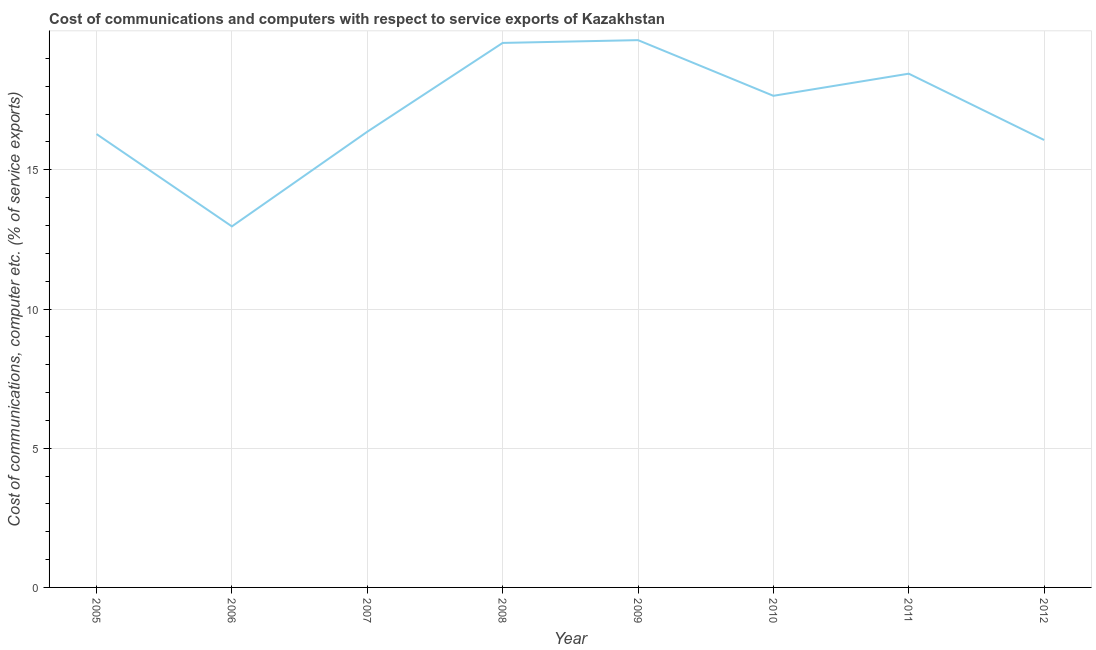What is the cost of communications and computer in 2007?
Keep it short and to the point. 16.37. Across all years, what is the maximum cost of communications and computer?
Your answer should be compact. 19.66. Across all years, what is the minimum cost of communications and computer?
Your response must be concise. 12.97. In which year was the cost of communications and computer minimum?
Offer a terse response. 2006. What is the sum of the cost of communications and computer?
Offer a very short reply. 137.02. What is the difference between the cost of communications and computer in 2010 and 2011?
Keep it short and to the point. -0.79. What is the average cost of communications and computer per year?
Provide a short and direct response. 17.13. What is the median cost of communications and computer?
Give a very brief answer. 17.01. What is the ratio of the cost of communications and computer in 2005 to that in 2006?
Your answer should be compact. 1.26. Is the cost of communications and computer in 2007 less than that in 2011?
Your answer should be compact. Yes. Is the difference between the cost of communications and computer in 2007 and 2010 greater than the difference between any two years?
Offer a very short reply. No. What is the difference between the highest and the second highest cost of communications and computer?
Offer a terse response. 0.1. What is the difference between the highest and the lowest cost of communications and computer?
Offer a terse response. 6.69. Does the cost of communications and computer monotonically increase over the years?
Give a very brief answer. No. What is the difference between two consecutive major ticks on the Y-axis?
Your answer should be compact. 5. Are the values on the major ticks of Y-axis written in scientific E-notation?
Give a very brief answer. No. What is the title of the graph?
Your answer should be very brief. Cost of communications and computers with respect to service exports of Kazakhstan. What is the label or title of the X-axis?
Your answer should be very brief. Year. What is the label or title of the Y-axis?
Provide a succinct answer. Cost of communications, computer etc. (% of service exports). What is the Cost of communications, computer etc. (% of service exports) in 2005?
Your answer should be very brief. 16.28. What is the Cost of communications, computer etc. (% of service exports) in 2006?
Your response must be concise. 12.97. What is the Cost of communications, computer etc. (% of service exports) of 2007?
Give a very brief answer. 16.37. What is the Cost of communications, computer etc. (% of service exports) in 2008?
Provide a succinct answer. 19.56. What is the Cost of communications, computer etc. (% of service exports) in 2009?
Provide a succinct answer. 19.66. What is the Cost of communications, computer etc. (% of service exports) of 2010?
Keep it short and to the point. 17.66. What is the Cost of communications, computer etc. (% of service exports) of 2011?
Give a very brief answer. 18.45. What is the Cost of communications, computer etc. (% of service exports) of 2012?
Provide a short and direct response. 16.07. What is the difference between the Cost of communications, computer etc. (% of service exports) in 2005 and 2006?
Keep it short and to the point. 3.32. What is the difference between the Cost of communications, computer etc. (% of service exports) in 2005 and 2007?
Give a very brief answer. -0.08. What is the difference between the Cost of communications, computer etc. (% of service exports) in 2005 and 2008?
Keep it short and to the point. -3.27. What is the difference between the Cost of communications, computer etc. (% of service exports) in 2005 and 2009?
Ensure brevity in your answer.  -3.37. What is the difference between the Cost of communications, computer etc. (% of service exports) in 2005 and 2010?
Keep it short and to the point. -1.37. What is the difference between the Cost of communications, computer etc. (% of service exports) in 2005 and 2011?
Offer a very short reply. -2.17. What is the difference between the Cost of communications, computer etc. (% of service exports) in 2005 and 2012?
Your response must be concise. 0.21. What is the difference between the Cost of communications, computer etc. (% of service exports) in 2006 and 2007?
Make the answer very short. -3.4. What is the difference between the Cost of communications, computer etc. (% of service exports) in 2006 and 2008?
Your answer should be compact. -6.59. What is the difference between the Cost of communications, computer etc. (% of service exports) in 2006 and 2009?
Provide a short and direct response. -6.69. What is the difference between the Cost of communications, computer etc. (% of service exports) in 2006 and 2010?
Offer a terse response. -4.69. What is the difference between the Cost of communications, computer etc. (% of service exports) in 2006 and 2011?
Make the answer very short. -5.49. What is the difference between the Cost of communications, computer etc. (% of service exports) in 2006 and 2012?
Provide a short and direct response. -3.1. What is the difference between the Cost of communications, computer etc. (% of service exports) in 2007 and 2008?
Offer a very short reply. -3.19. What is the difference between the Cost of communications, computer etc. (% of service exports) in 2007 and 2009?
Offer a very short reply. -3.29. What is the difference between the Cost of communications, computer etc. (% of service exports) in 2007 and 2010?
Give a very brief answer. -1.29. What is the difference between the Cost of communications, computer etc. (% of service exports) in 2007 and 2011?
Your answer should be very brief. -2.09. What is the difference between the Cost of communications, computer etc. (% of service exports) in 2007 and 2012?
Keep it short and to the point. 0.3. What is the difference between the Cost of communications, computer etc. (% of service exports) in 2008 and 2009?
Ensure brevity in your answer.  -0.1. What is the difference between the Cost of communications, computer etc. (% of service exports) in 2008 and 2010?
Your answer should be very brief. 1.9. What is the difference between the Cost of communications, computer etc. (% of service exports) in 2008 and 2011?
Your response must be concise. 1.1. What is the difference between the Cost of communications, computer etc. (% of service exports) in 2008 and 2012?
Offer a very short reply. 3.49. What is the difference between the Cost of communications, computer etc. (% of service exports) in 2009 and 2010?
Your answer should be compact. 2. What is the difference between the Cost of communications, computer etc. (% of service exports) in 2009 and 2011?
Your response must be concise. 1.2. What is the difference between the Cost of communications, computer etc. (% of service exports) in 2009 and 2012?
Ensure brevity in your answer.  3.59. What is the difference between the Cost of communications, computer etc. (% of service exports) in 2010 and 2011?
Keep it short and to the point. -0.79. What is the difference between the Cost of communications, computer etc. (% of service exports) in 2010 and 2012?
Your answer should be compact. 1.59. What is the difference between the Cost of communications, computer etc. (% of service exports) in 2011 and 2012?
Keep it short and to the point. 2.38. What is the ratio of the Cost of communications, computer etc. (% of service exports) in 2005 to that in 2006?
Provide a succinct answer. 1.26. What is the ratio of the Cost of communications, computer etc. (% of service exports) in 2005 to that in 2008?
Your answer should be very brief. 0.83. What is the ratio of the Cost of communications, computer etc. (% of service exports) in 2005 to that in 2009?
Your answer should be very brief. 0.83. What is the ratio of the Cost of communications, computer etc. (% of service exports) in 2005 to that in 2010?
Ensure brevity in your answer.  0.92. What is the ratio of the Cost of communications, computer etc. (% of service exports) in 2005 to that in 2011?
Keep it short and to the point. 0.88. What is the ratio of the Cost of communications, computer etc. (% of service exports) in 2005 to that in 2012?
Keep it short and to the point. 1.01. What is the ratio of the Cost of communications, computer etc. (% of service exports) in 2006 to that in 2007?
Give a very brief answer. 0.79. What is the ratio of the Cost of communications, computer etc. (% of service exports) in 2006 to that in 2008?
Offer a very short reply. 0.66. What is the ratio of the Cost of communications, computer etc. (% of service exports) in 2006 to that in 2009?
Your answer should be compact. 0.66. What is the ratio of the Cost of communications, computer etc. (% of service exports) in 2006 to that in 2010?
Your answer should be compact. 0.73. What is the ratio of the Cost of communications, computer etc. (% of service exports) in 2006 to that in 2011?
Make the answer very short. 0.7. What is the ratio of the Cost of communications, computer etc. (% of service exports) in 2006 to that in 2012?
Keep it short and to the point. 0.81. What is the ratio of the Cost of communications, computer etc. (% of service exports) in 2007 to that in 2008?
Offer a terse response. 0.84. What is the ratio of the Cost of communications, computer etc. (% of service exports) in 2007 to that in 2009?
Provide a short and direct response. 0.83. What is the ratio of the Cost of communications, computer etc. (% of service exports) in 2007 to that in 2010?
Your answer should be compact. 0.93. What is the ratio of the Cost of communications, computer etc. (% of service exports) in 2007 to that in 2011?
Provide a short and direct response. 0.89. What is the ratio of the Cost of communications, computer etc. (% of service exports) in 2008 to that in 2010?
Keep it short and to the point. 1.11. What is the ratio of the Cost of communications, computer etc. (% of service exports) in 2008 to that in 2011?
Offer a terse response. 1.06. What is the ratio of the Cost of communications, computer etc. (% of service exports) in 2008 to that in 2012?
Keep it short and to the point. 1.22. What is the ratio of the Cost of communications, computer etc. (% of service exports) in 2009 to that in 2010?
Provide a succinct answer. 1.11. What is the ratio of the Cost of communications, computer etc. (% of service exports) in 2009 to that in 2011?
Your answer should be compact. 1.06. What is the ratio of the Cost of communications, computer etc. (% of service exports) in 2009 to that in 2012?
Provide a succinct answer. 1.22. What is the ratio of the Cost of communications, computer etc. (% of service exports) in 2010 to that in 2012?
Ensure brevity in your answer.  1.1. What is the ratio of the Cost of communications, computer etc. (% of service exports) in 2011 to that in 2012?
Provide a short and direct response. 1.15. 